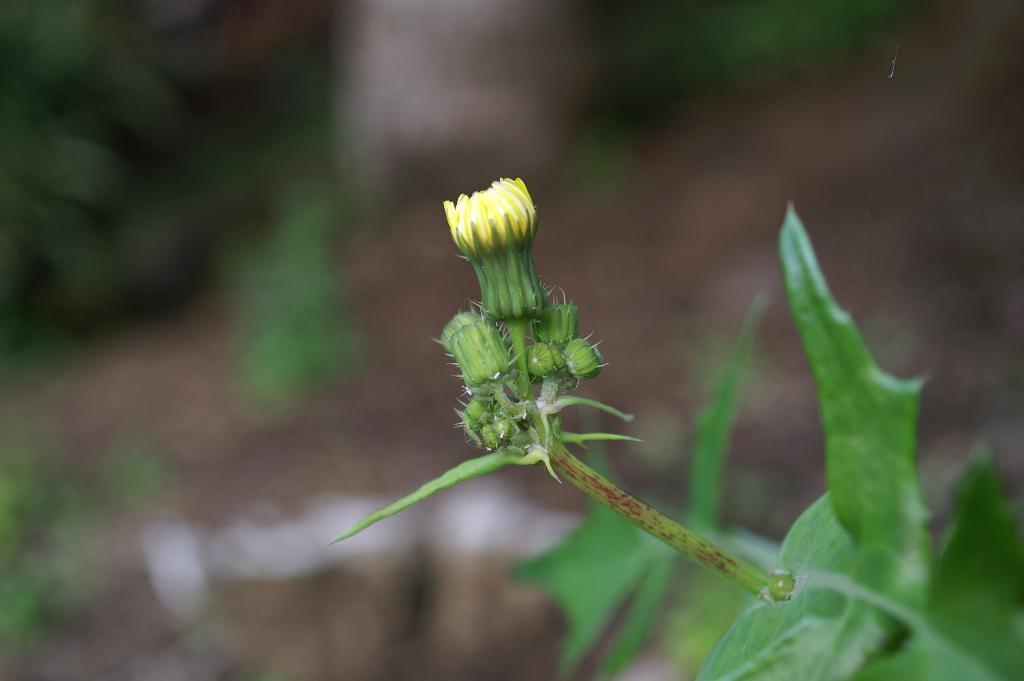In one or two sentences, can you explain what this image depicts? In this image we can see some buds, stem and leaves of a plant. 